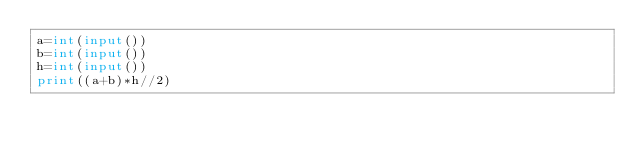<code> <loc_0><loc_0><loc_500><loc_500><_Python_>a=int(input())
b=int(input())
h=int(input())
print((a+b)*h//2)
</code> 